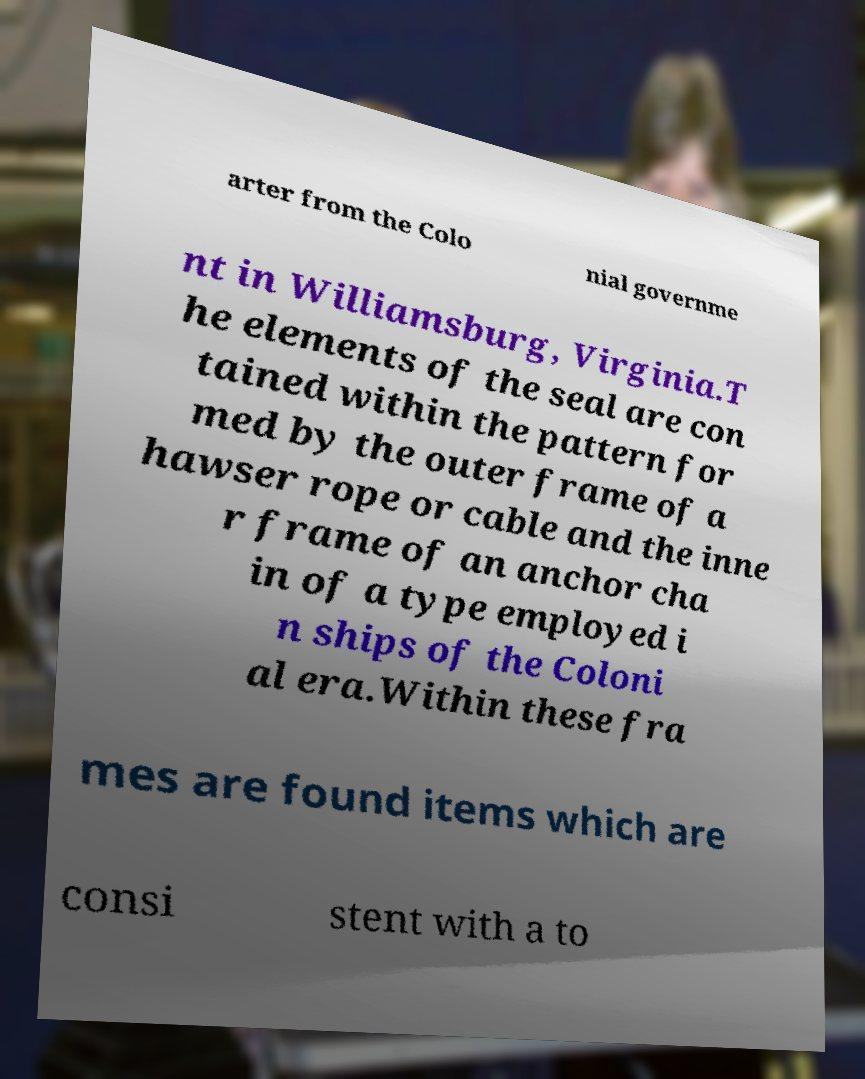For documentation purposes, I need the text within this image transcribed. Could you provide that? arter from the Colo nial governme nt in Williamsburg, Virginia.T he elements of the seal are con tained within the pattern for med by the outer frame of a hawser rope or cable and the inne r frame of an anchor cha in of a type employed i n ships of the Coloni al era.Within these fra mes are found items which are consi stent with a to 